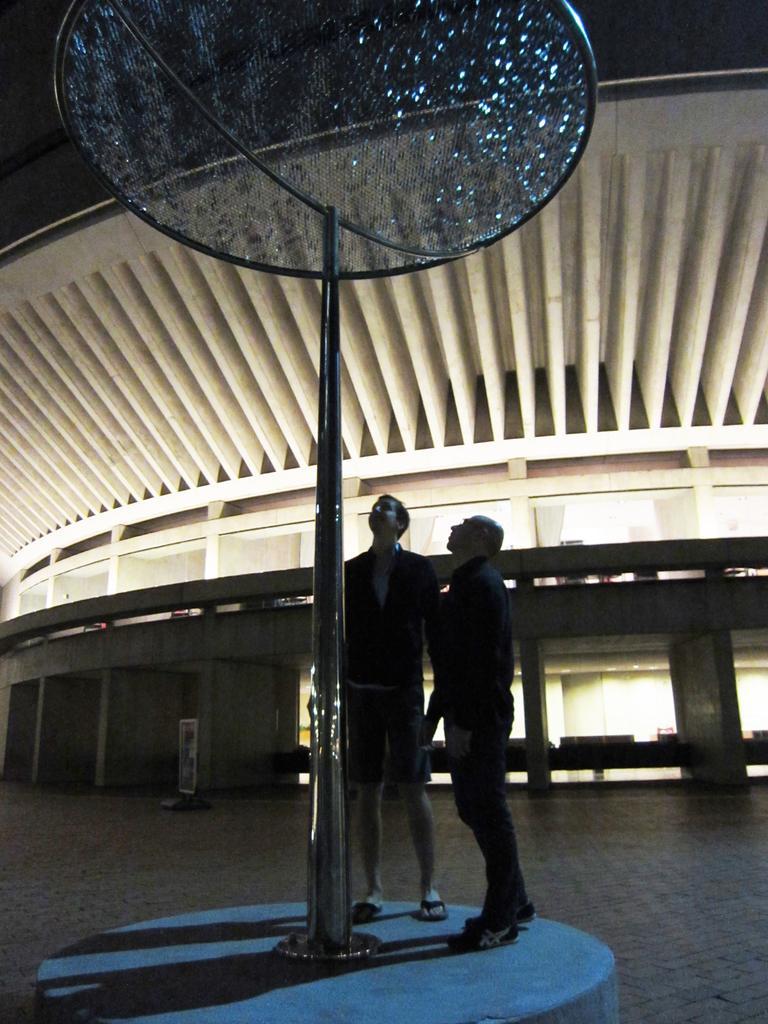Can you describe this image briefly? Here we can see two persons and there is a pole. In the background we can see a building. 